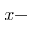<formula> <loc_0><loc_0><loc_500><loc_500>x -</formula> 